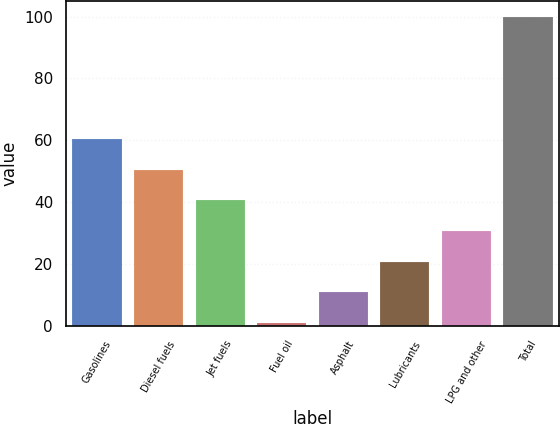<chart> <loc_0><loc_0><loc_500><loc_500><bar_chart><fcel>Gasolines<fcel>Diesel fuels<fcel>Jet fuels<fcel>Fuel oil<fcel>Asphalt<fcel>Lubricants<fcel>LPG and other<fcel>Total<nl><fcel>60.4<fcel>50.5<fcel>40.6<fcel>1<fcel>10.9<fcel>20.8<fcel>30.7<fcel>100<nl></chart> 